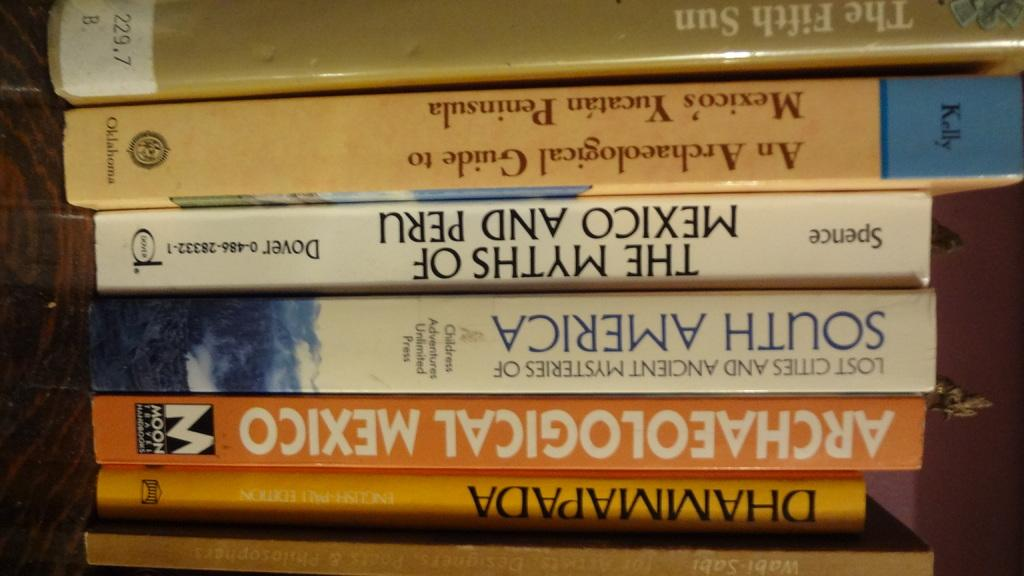<image>
Summarize the visual content of the image. a stack of books with one of them titled 'archaeological mexico' 